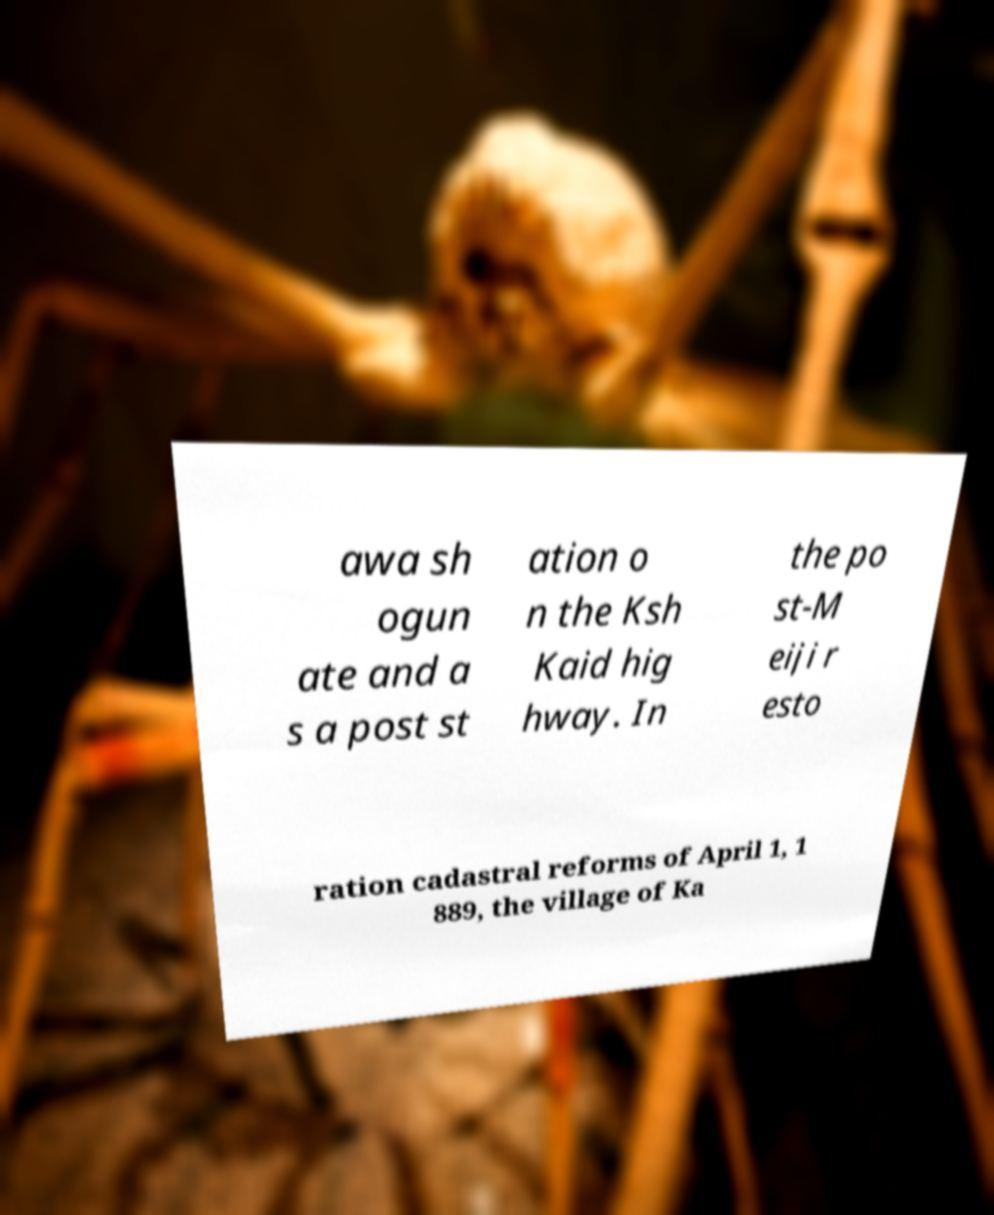Could you extract and type out the text from this image? awa sh ogun ate and a s a post st ation o n the Ksh Kaid hig hway. In the po st-M eiji r esto ration cadastral reforms of April 1, 1 889, the village of Ka 